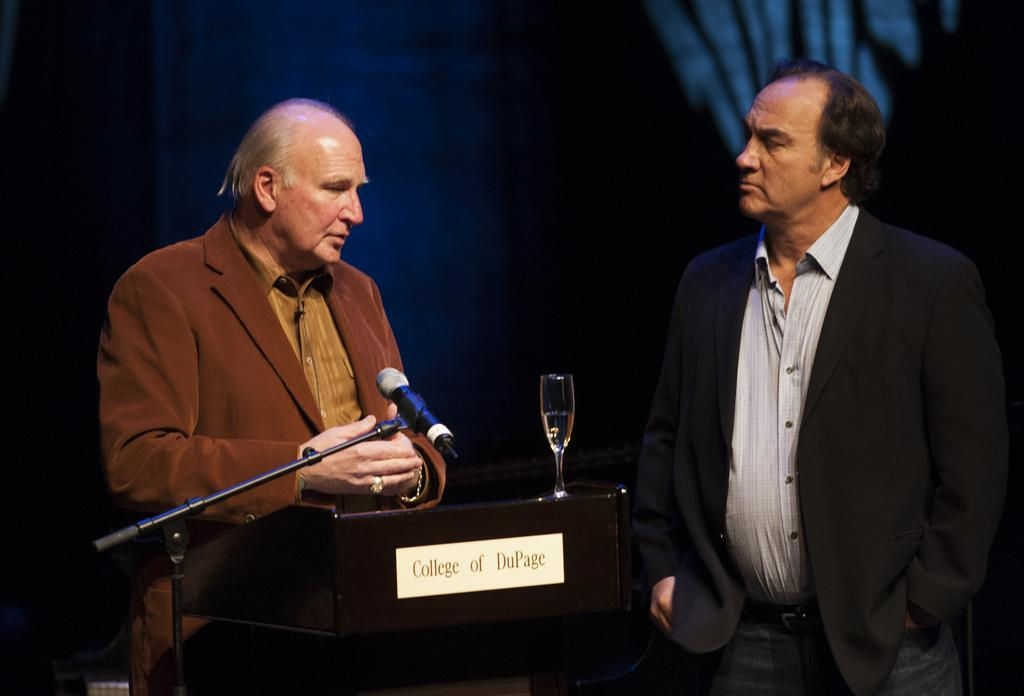What is the man in the black suit wearing in the image? The man in the black suit is wearing a black suit in the image. Where is the man in the black suit standing in relation to the old man in the brown suit? The man in the black suit is standing on the right side, while the old man in the brown suit is standing on the left side. What is the old man in the brown suit standing behind in the image? The old man in the brown suit is standing behind a dias in the image. What objects are on the dias? There is a microphone and a wine glass on the dias. What type of science experiment is being conducted by the squirrel in the image? There is no squirrel present in the image, and therefore no science experiment can be observed. 